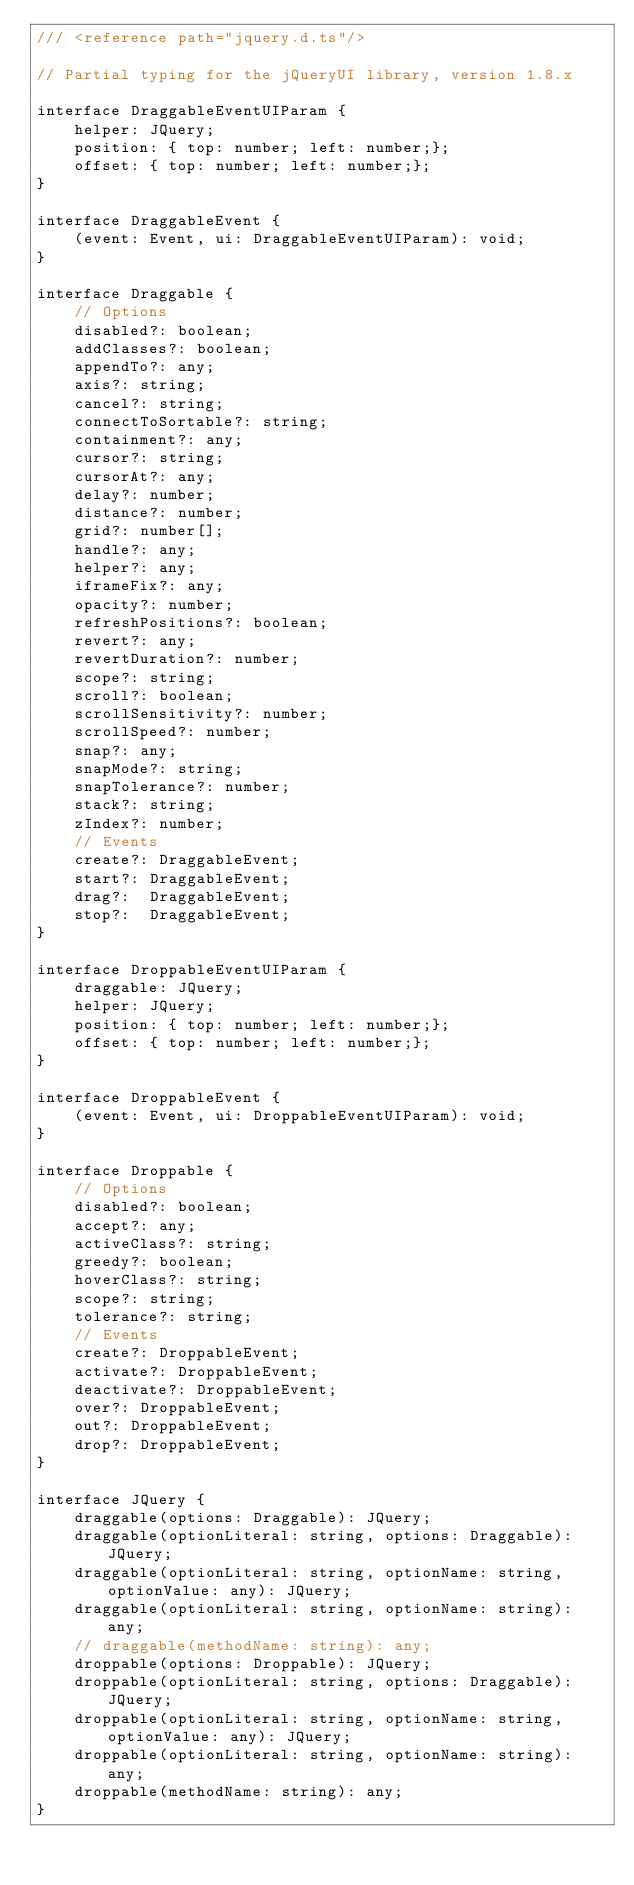<code> <loc_0><loc_0><loc_500><loc_500><_TypeScript_>/// <reference path="jquery.d.ts"/>

// Partial typing for the jQueryUI library, version 1.8.x

interface DraggableEventUIParam {
    helper: JQuery;
    position: { top: number; left: number;};
    offset: { top: number; left: number;};
}

interface DraggableEvent {
    (event: Event, ui: DraggableEventUIParam): void;
}

interface Draggable {
    // Options
    disabled?: boolean;
    addClasses?: boolean;
    appendTo?: any;
    axis?: string;
    cancel?: string;
    connectToSortable?: string;
    containment?: any;
    cursor?: string;
    cursorAt?: any;
    delay?: number;
    distance?: number;
    grid?: number[];
    handle?: any;
    helper?: any;
    iframeFix?: any;
    opacity?: number;
    refreshPositions?: boolean;
    revert?: any;
    revertDuration?: number;
    scope?: string;
    scroll?: boolean;
    scrollSensitivity?: number;
    scrollSpeed?: number;
    snap?: any;
    snapMode?: string;
    snapTolerance?: number;
    stack?: string;
    zIndex?: number;
    // Events
    create?: DraggableEvent;
    start?: DraggableEvent;
    drag?:  DraggableEvent;
    stop?:  DraggableEvent;
}

interface DroppableEventUIParam {
    draggable: JQuery;
    helper: JQuery;
    position: { top: number; left: number;};
    offset: { top: number; left: number;};
}

interface DroppableEvent {
    (event: Event, ui: DroppableEventUIParam): void;
}

interface Droppable {
    // Options
    disabled?: boolean;
    accept?: any;
    activeClass?: string;
    greedy?: boolean;
    hoverClass?: string;
    scope?: string;
    tolerance?: string;
    // Events
    create?: DroppableEvent;
    activate?: DroppableEvent;
    deactivate?: DroppableEvent;
    over?: DroppableEvent;
    out?: DroppableEvent;
    drop?: DroppableEvent;
}

interface JQuery {
    draggable(options: Draggable): JQuery;
    draggable(optionLiteral: string, options: Draggable): JQuery;
    draggable(optionLiteral: string, optionName: string, optionValue: any): JQuery;
    draggable(optionLiteral: string, optionName: string): any;
    // draggable(methodName: string): any;
    droppable(options: Droppable): JQuery;
    droppable(optionLiteral: string, options: Draggable): JQuery;
    droppable(optionLiteral: string, optionName: string, optionValue: any): JQuery;
    droppable(optionLiteral: string, optionName: string): any;
    droppable(methodName: string): any;
}
</code> 